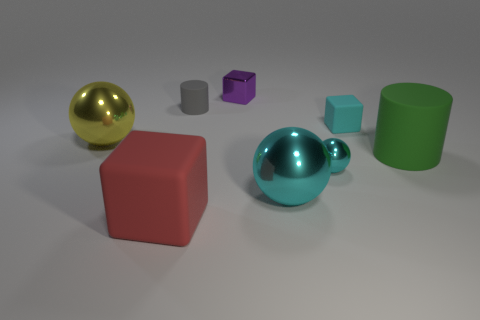How many big red rubber blocks are behind the sphere that is to the left of the rubber cylinder that is on the left side of the green thing?
Provide a succinct answer. 0. There is a big matte thing that is right of the large cyan metallic object on the right side of the large red object; what color is it?
Give a very brief answer. Green. There is a tiny matte object on the left side of the large cyan sphere; what number of small blocks are on the right side of it?
Keep it short and to the point. 2. Are there any other things that are the same shape as the small purple object?
Your answer should be very brief. Yes. Is the color of the cylinder that is to the right of the tiny matte block the same as the block that is in front of the small cyan rubber block?
Give a very brief answer. No. Are there fewer small cyan matte cubes than cyan metal balls?
Provide a succinct answer. Yes. What is the shape of the tiny metallic object right of the cyan metallic ball in front of the tiny cyan shiny sphere?
Offer a very short reply. Sphere. The large object that is right of the big metal ball to the right of the cylinder that is to the left of the small shiny block is what shape?
Provide a short and direct response. Cylinder. How many things are either tiny cyan rubber cubes behind the large cyan metal thing or rubber blocks that are on the right side of the large red thing?
Make the answer very short. 1. There is a green rubber object; is its size the same as the block that is in front of the large cylinder?
Provide a succinct answer. Yes. 